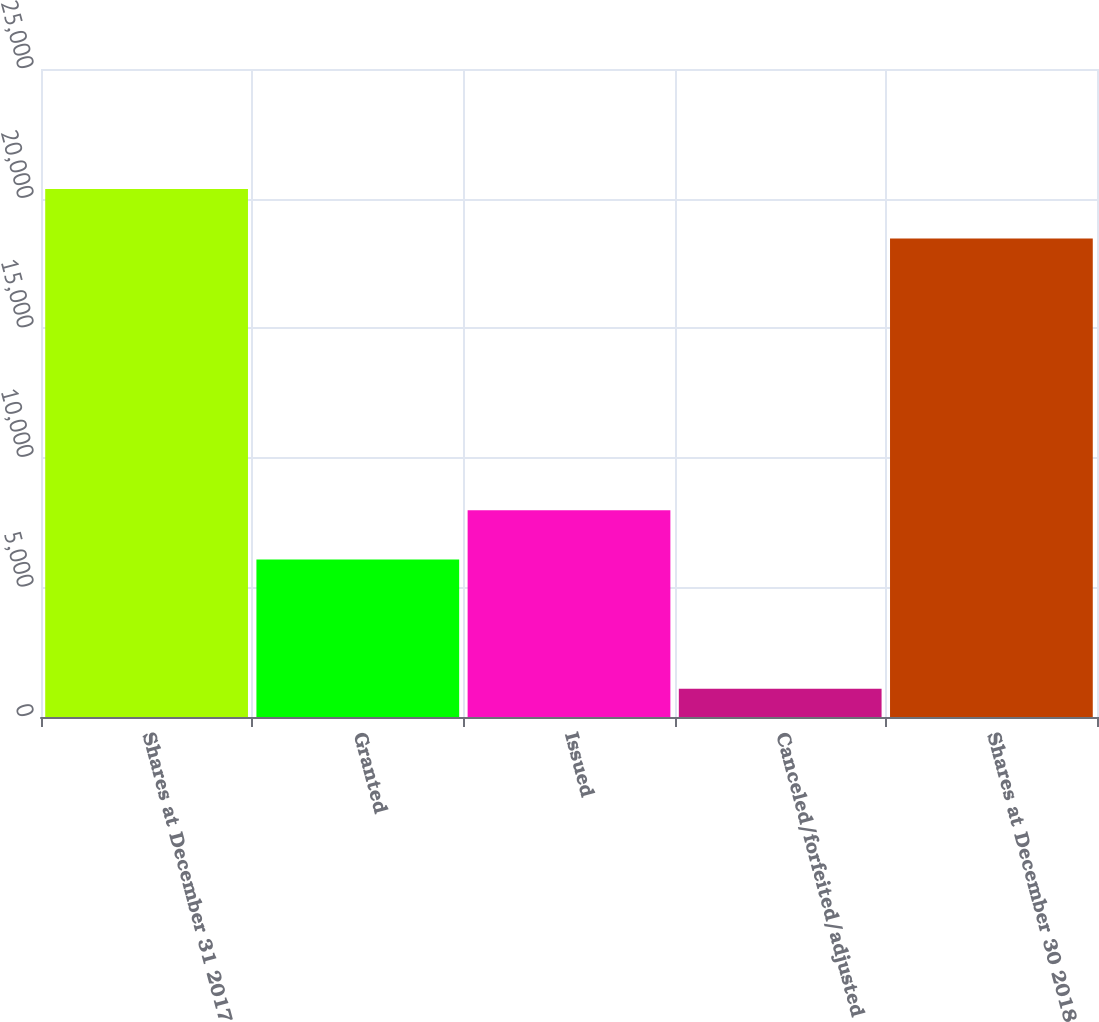Convert chart. <chart><loc_0><loc_0><loc_500><loc_500><bar_chart><fcel>Shares at December 31 2017<fcel>Granted<fcel>Issued<fcel>Canceled/forfeited/adjusted<fcel>Shares at December 30 2018<nl><fcel>20367<fcel>6074<fcel>7981<fcel>1091<fcel>18460<nl></chart> 